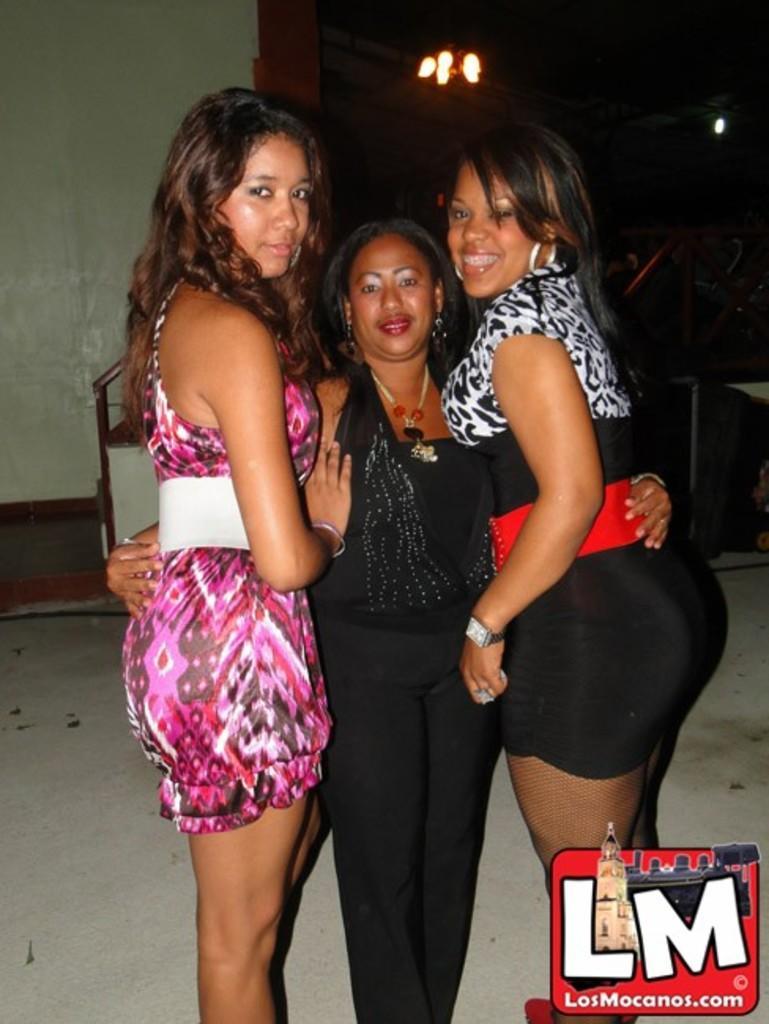How would you summarize this image in a sentence or two? In the middle of the image three women are standing and smiling. Behind them there is wall, on the wall there is light. 